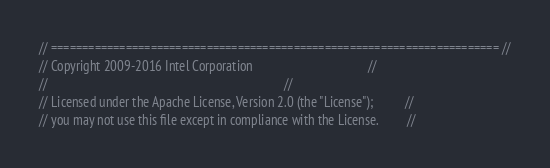Convert code to text. <code><loc_0><loc_0><loc_500><loc_500><_C_>// ======================================================================== //
// Copyright 2009-2016 Intel Corporation                                    //
//                                                                          //
// Licensed under the Apache License, Version 2.0 (the "License");          //
// you may not use this file except in compliance with the License.         //</code> 